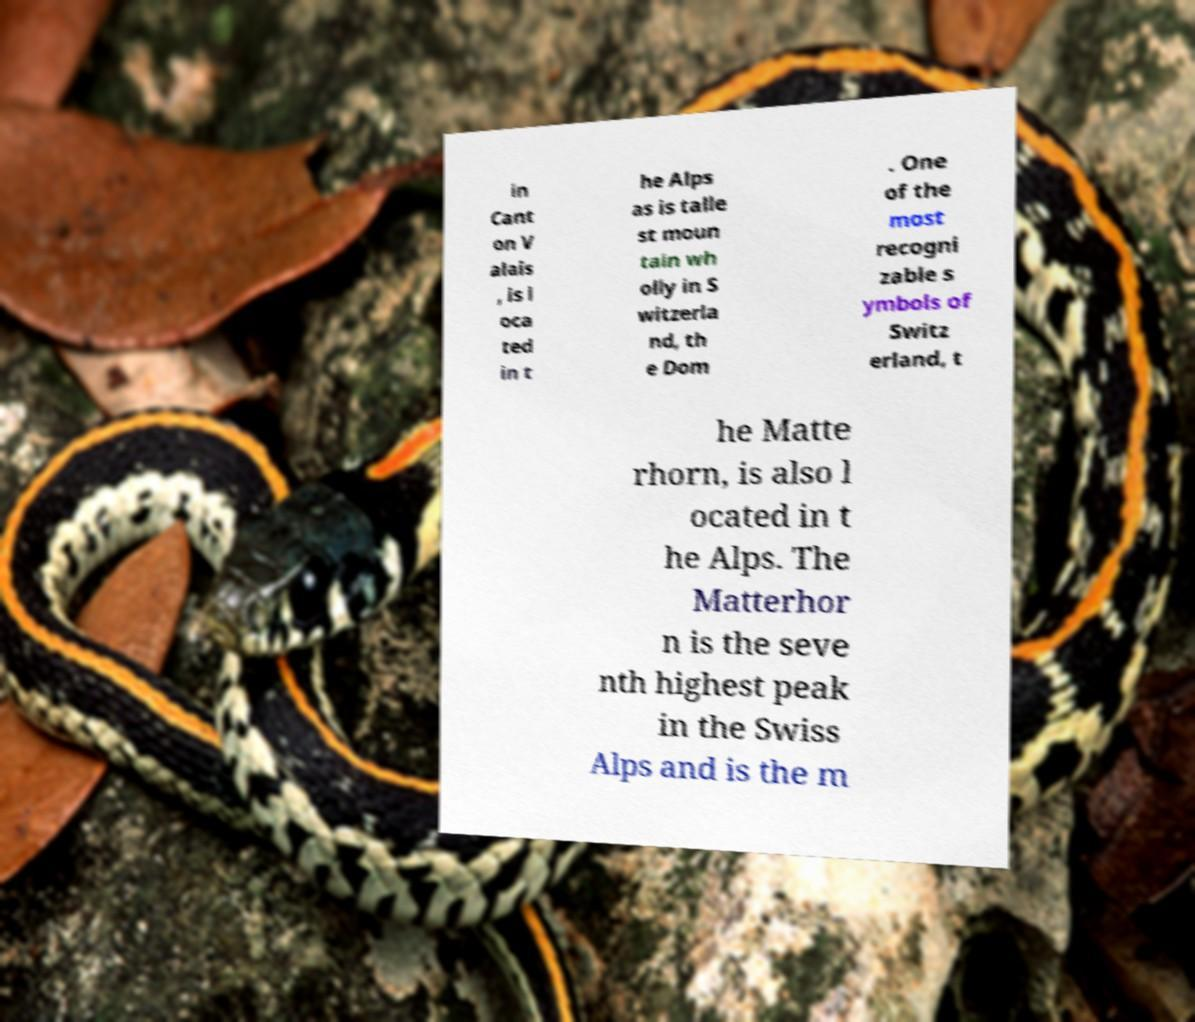There's text embedded in this image that I need extracted. Can you transcribe it verbatim? in Cant on V alais , is l oca ted in t he Alps as is talle st moun tain wh olly in S witzerla nd, th e Dom . One of the most recogni zable s ymbols of Switz erland, t he Matte rhorn, is also l ocated in t he Alps. The Matterhor n is the seve nth highest peak in the Swiss Alps and is the m 